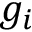Convert formula to latex. <formula><loc_0><loc_0><loc_500><loc_500>g _ { i }</formula> 